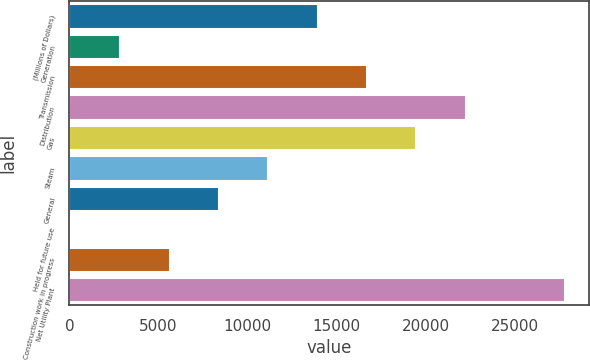<chart> <loc_0><loc_0><loc_500><loc_500><bar_chart><fcel>(Millions of Dollars)<fcel>Generation<fcel>Transmission<fcel>Distribution<fcel>Gas<fcel>Steam<fcel>General<fcel>Held for future use<fcel>Construction work in progress<fcel>Net Utility Plant<nl><fcel>13934<fcel>2845.2<fcel>16706.2<fcel>22250.6<fcel>19478.4<fcel>11161.8<fcel>8389.6<fcel>73<fcel>5617.4<fcel>27795<nl></chart> 